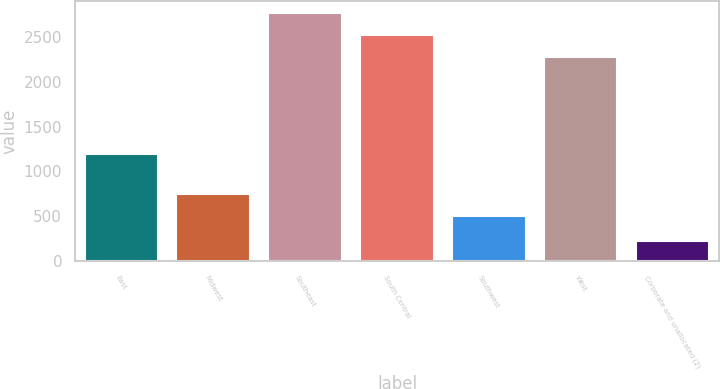Convert chart. <chart><loc_0><loc_0><loc_500><loc_500><bar_chart><fcel>East<fcel>Midwest<fcel>Southeast<fcel>South Central<fcel>Southwest<fcel>West<fcel>Corporate and unallocated (2)<nl><fcel>1192<fcel>744.2<fcel>2757.5<fcel>2513<fcel>499.7<fcel>2268.5<fcel>223.7<nl></chart> 